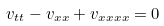Convert formula to latex. <formula><loc_0><loc_0><loc_500><loc_500>v _ { t t } - v _ { x x } + v _ { x x x x } = 0</formula> 